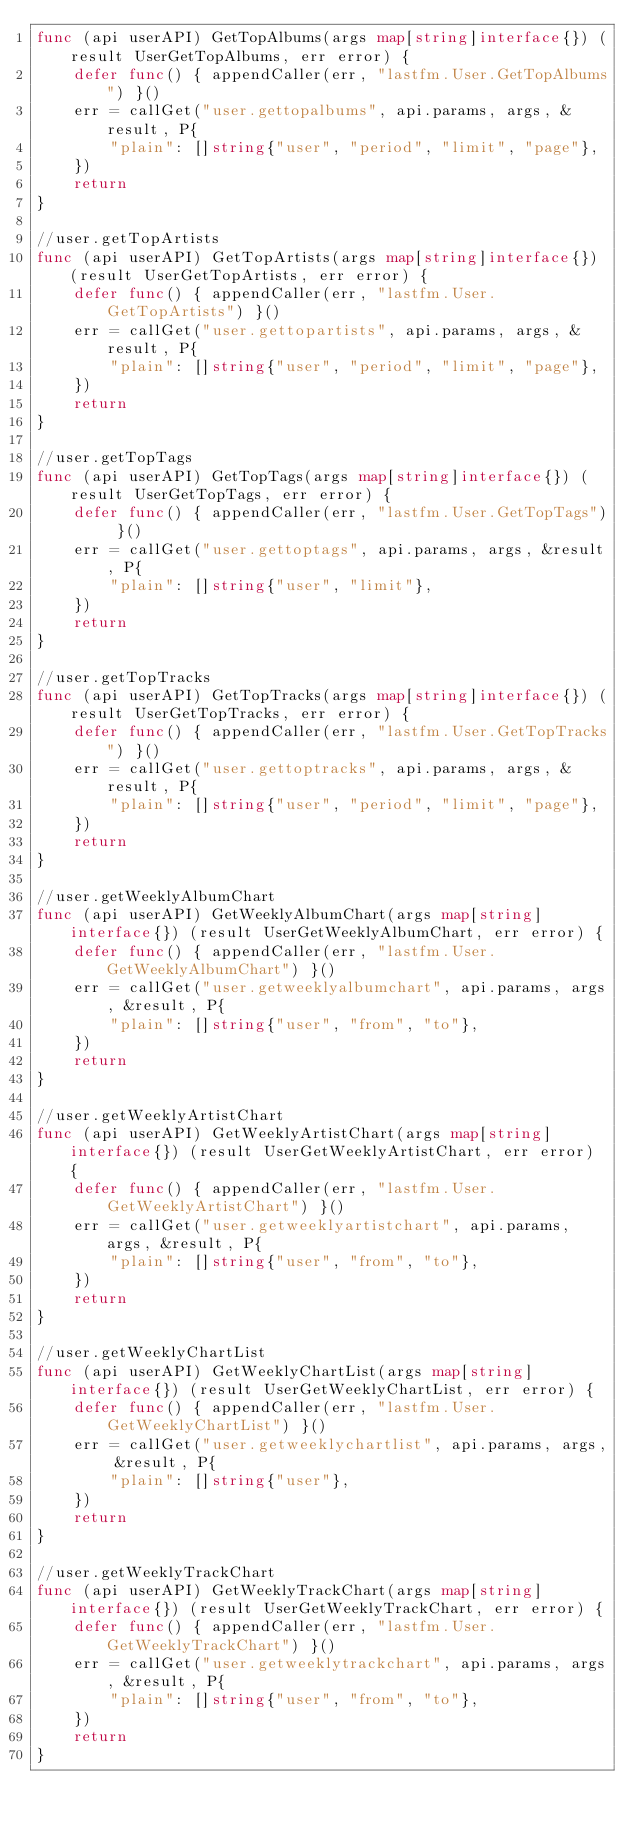<code> <loc_0><loc_0><loc_500><loc_500><_Go_>func (api userAPI) GetTopAlbums(args map[string]interface{}) (result UserGetTopAlbums, err error) {
	defer func() { appendCaller(err, "lastfm.User.GetTopAlbums") }()
	err = callGet("user.gettopalbums", api.params, args, &result, P{
		"plain": []string{"user", "period", "limit", "page"},
	})
	return
}

//user.getTopArtists
func (api userAPI) GetTopArtists(args map[string]interface{}) (result UserGetTopArtists, err error) {
	defer func() { appendCaller(err, "lastfm.User.GetTopArtists") }()
	err = callGet("user.gettopartists", api.params, args, &result, P{
		"plain": []string{"user", "period", "limit", "page"},
	})
	return
}

//user.getTopTags
func (api userAPI) GetTopTags(args map[string]interface{}) (result UserGetTopTags, err error) {
	defer func() { appendCaller(err, "lastfm.User.GetTopTags") }()
	err = callGet("user.gettoptags", api.params, args, &result, P{
		"plain": []string{"user", "limit"},
	})
	return
}

//user.getTopTracks
func (api userAPI) GetTopTracks(args map[string]interface{}) (result UserGetTopTracks, err error) {
	defer func() { appendCaller(err, "lastfm.User.GetTopTracks") }()
	err = callGet("user.gettoptracks", api.params, args, &result, P{
		"plain": []string{"user", "period", "limit", "page"},
	})
	return
}

//user.getWeeklyAlbumChart
func (api userAPI) GetWeeklyAlbumChart(args map[string]interface{}) (result UserGetWeeklyAlbumChart, err error) {
	defer func() { appendCaller(err, "lastfm.User.GetWeeklyAlbumChart") }()
	err = callGet("user.getweeklyalbumchart", api.params, args, &result, P{
		"plain": []string{"user", "from", "to"},
	})
	return
}

//user.getWeeklyArtistChart
func (api userAPI) GetWeeklyArtistChart(args map[string]interface{}) (result UserGetWeeklyArtistChart, err error) {
	defer func() { appendCaller(err, "lastfm.User.GetWeeklyArtistChart") }()
	err = callGet("user.getweeklyartistchart", api.params, args, &result, P{
		"plain": []string{"user", "from", "to"},
	})
	return
}

//user.getWeeklyChartList
func (api userAPI) GetWeeklyChartList(args map[string]interface{}) (result UserGetWeeklyChartList, err error) {
	defer func() { appendCaller(err, "lastfm.User.GetWeeklyChartList") }()
	err = callGet("user.getweeklychartlist", api.params, args, &result, P{
		"plain": []string{"user"},
	})
	return
}

//user.getWeeklyTrackChart
func (api userAPI) GetWeeklyTrackChart(args map[string]interface{}) (result UserGetWeeklyTrackChart, err error) {
	defer func() { appendCaller(err, "lastfm.User.GetWeeklyTrackChart") }()
	err = callGet("user.getweeklytrackchart", api.params, args, &result, P{
		"plain": []string{"user", "from", "to"},
	})
	return
}
</code> 